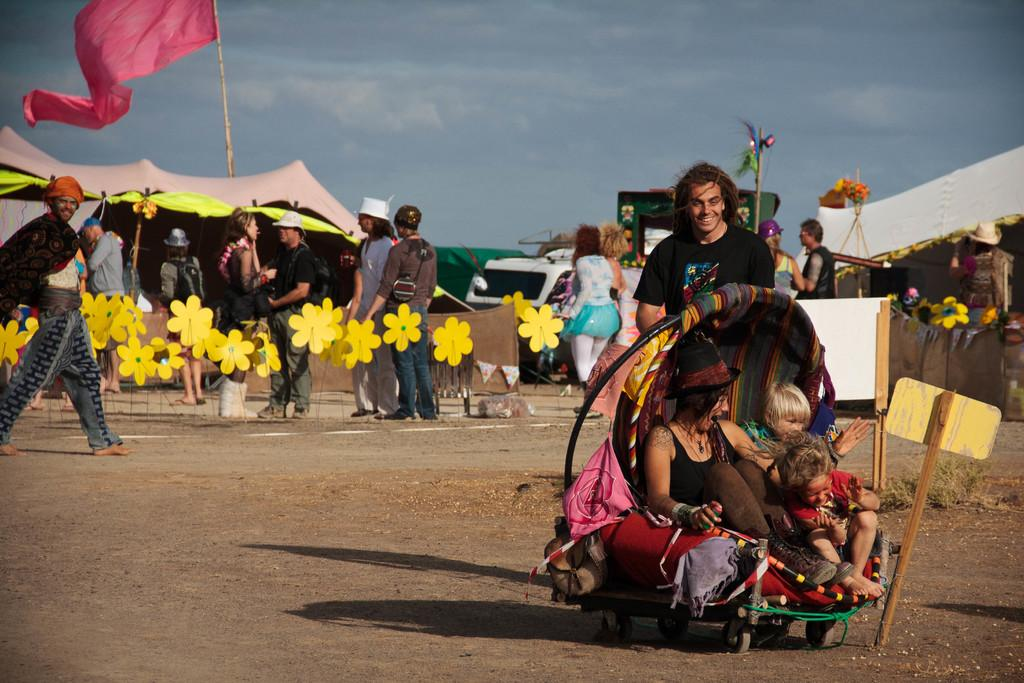What are the people in the image doing? There are people in a trolley in the image. What can be seen in the background of the image? There are tents, flags, and people standing in the background of the image. What objects are visible in the image? There are boards and paper sticks visible in the image. What type of berry is being glued onto the boards in the image? There is no berry or glue present in the image; the objects mentioned are boards and paper sticks. 